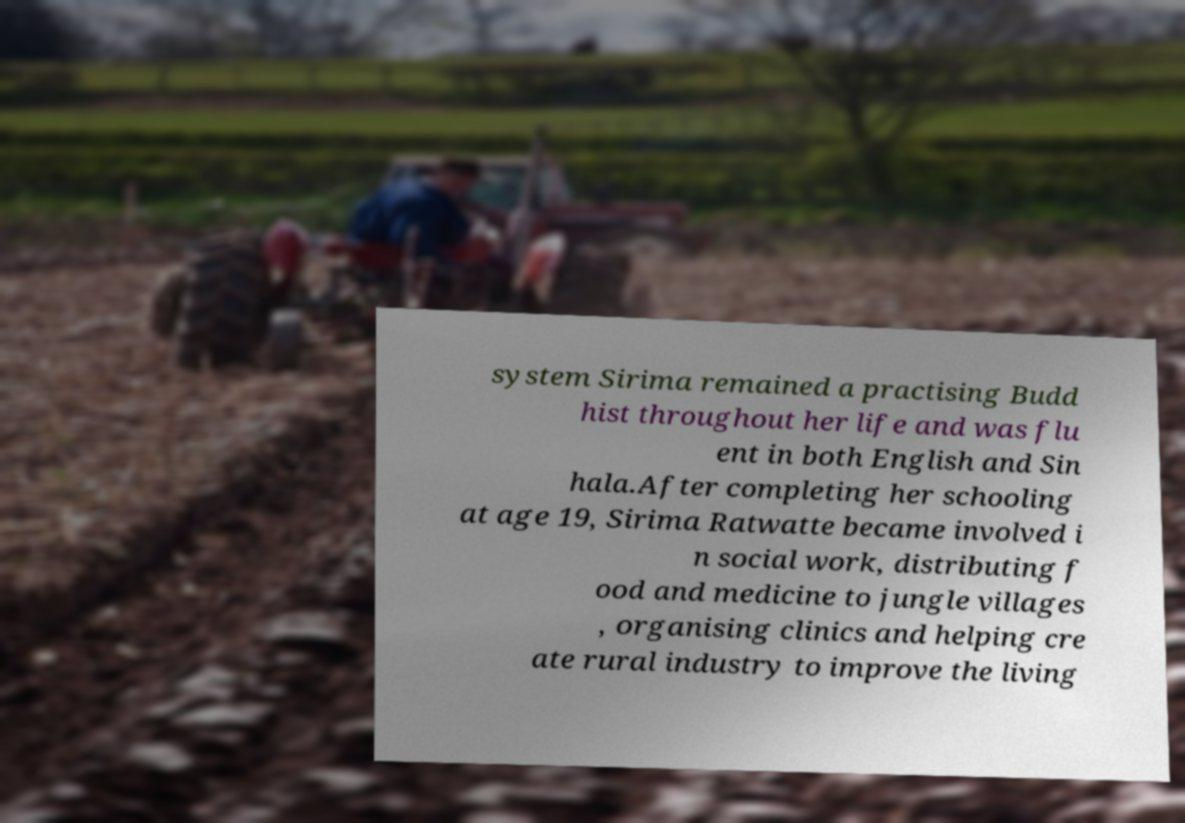Please read and relay the text visible in this image. What does it say? system Sirima remained a practising Budd hist throughout her life and was flu ent in both English and Sin hala.After completing her schooling at age 19, Sirima Ratwatte became involved i n social work, distributing f ood and medicine to jungle villages , organising clinics and helping cre ate rural industry to improve the living 